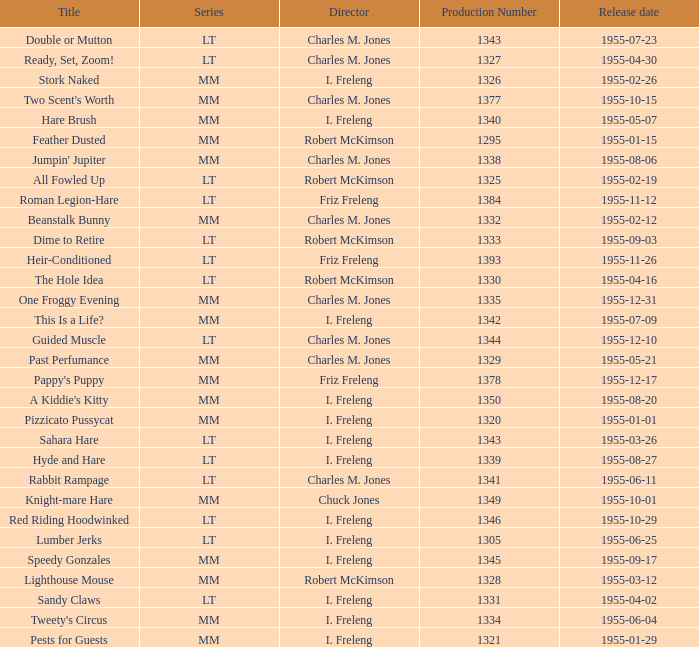What is the title with the production number greater than 1334 released on 1955-08-27? Hyde and Hare. 